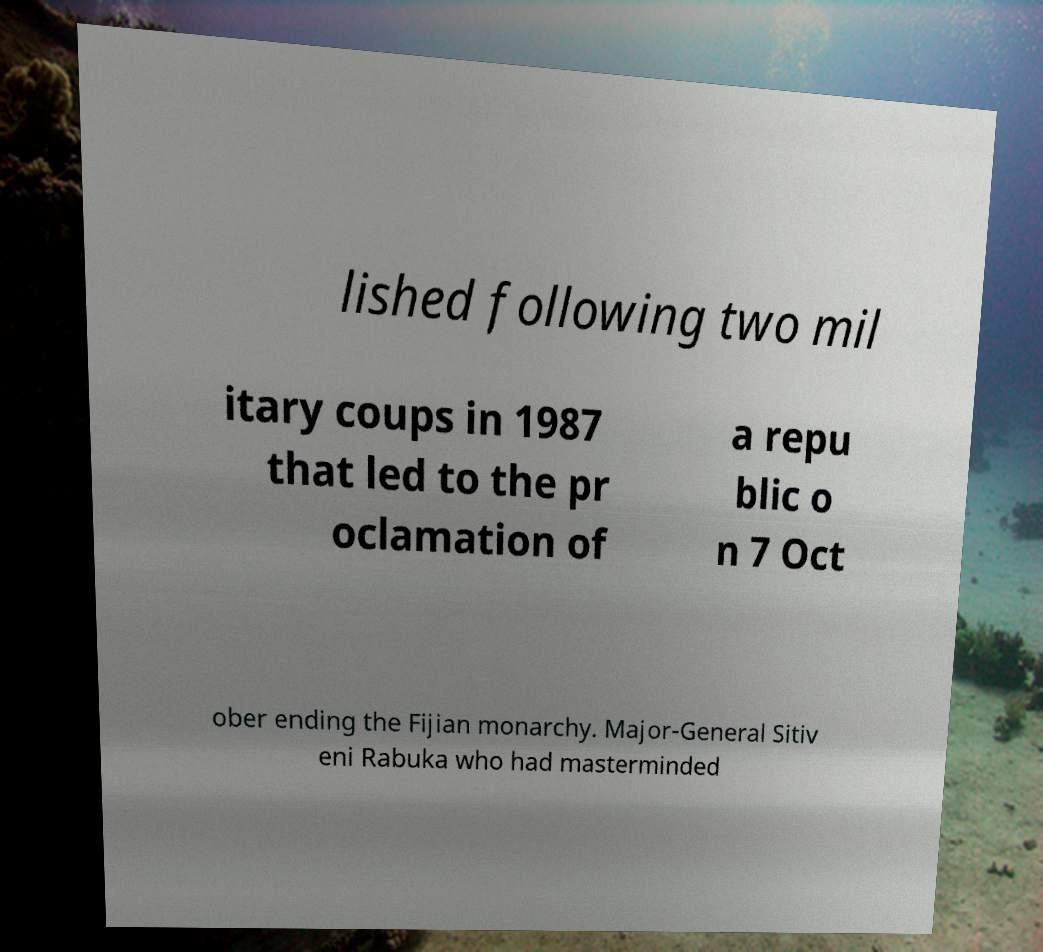Can you read and provide the text displayed in the image?This photo seems to have some interesting text. Can you extract and type it out for me? lished following two mil itary coups in 1987 that led to the pr oclamation of a repu blic o n 7 Oct ober ending the Fijian monarchy. Major-General Sitiv eni Rabuka who had masterminded 